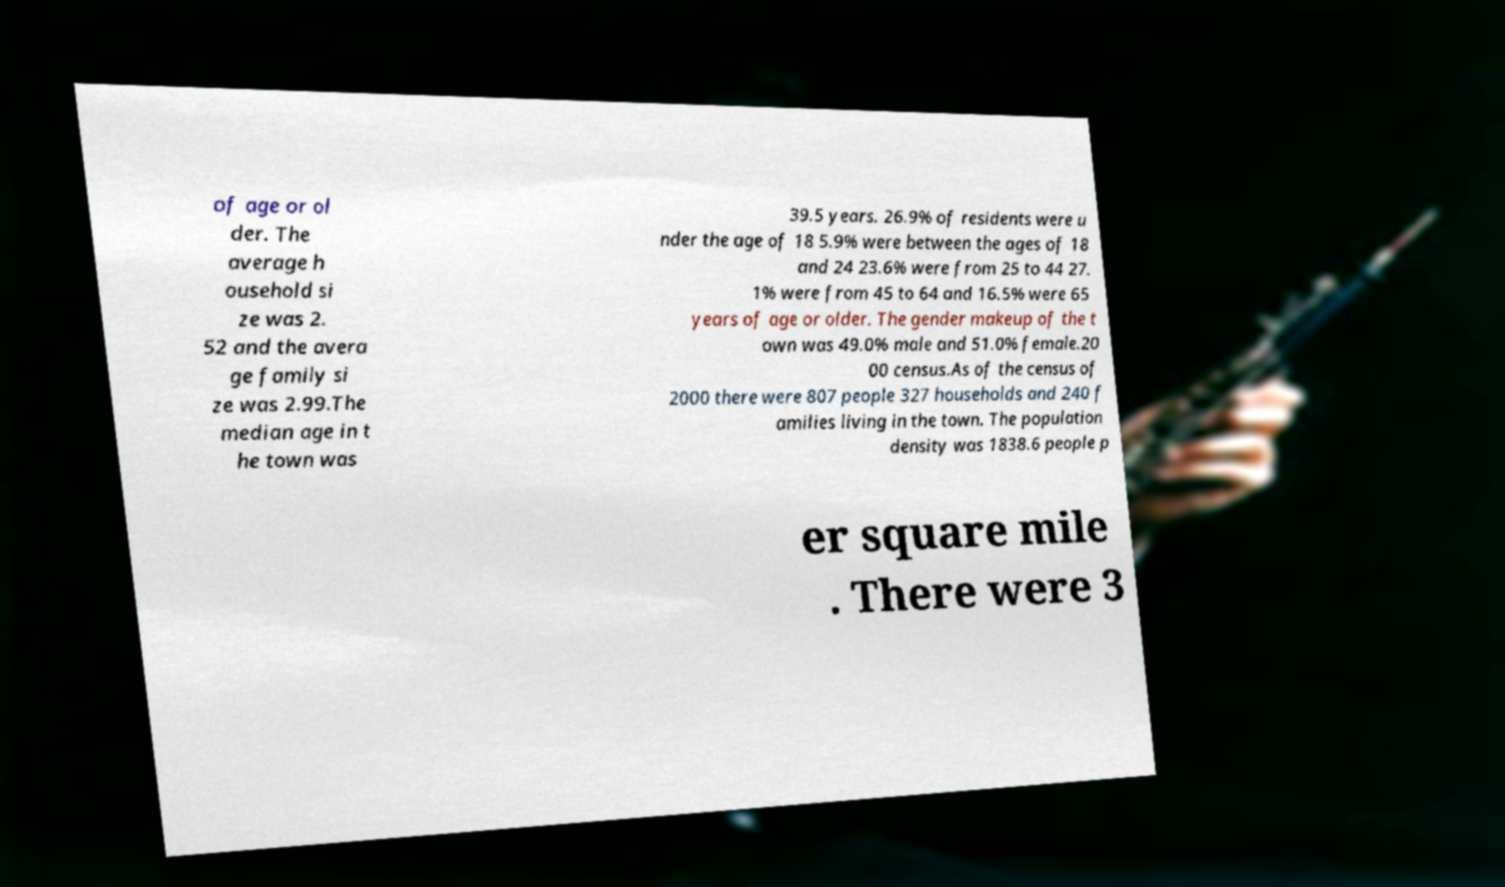There's text embedded in this image that I need extracted. Can you transcribe it verbatim? of age or ol der. The average h ousehold si ze was 2. 52 and the avera ge family si ze was 2.99.The median age in t he town was 39.5 years. 26.9% of residents were u nder the age of 18 5.9% were between the ages of 18 and 24 23.6% were from 25 to 44 27. 1% were from 45 to 64 and 16.5% were 65 years of age or older. The gender makeup of the t own was 49.0% male and 51.0% female.20 00 census.As of the census of 2000 there were 807 people 327 households and 240 f amilies living in the town. The population density was 1838.6 people p er square mile . There were 3 